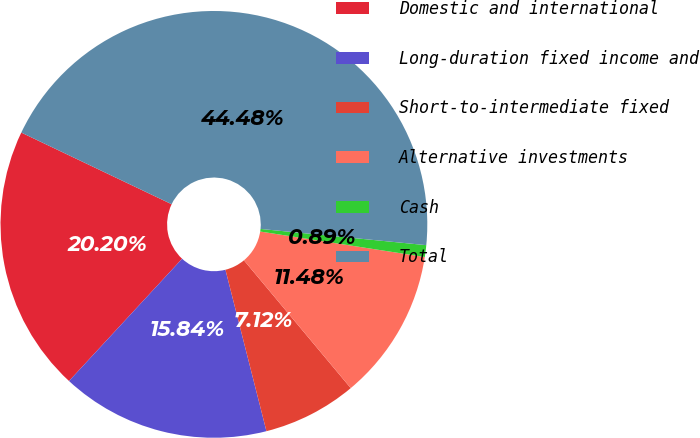Convert chart. <chart><loc_0><loc_0><loc_500><loc_500><pie_chart><fcel>Domestic and international<fcel>Long-duration fixed income and<fcel>Short-to-intermediate fixed<fcel>Alternative investments<fcel>Cash<fcel>Total<nl><fcel>20.2%<fcel>15.84%<fcel>7.12%<fcel>11.48%<fcel>0.89%<fcel>44.48%<nl></chart> 